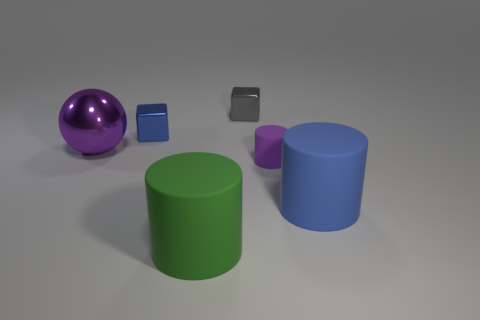Subtract 1 cylinders. How many cylinders are left? 2 Add 2 yellow things. How many objects exist? 8 Subtract all red blocks. Subtract all blue cylinders. How many blocks are left? 2 Subtract all cubes. How many objects are left? 4 Add 3 large purple shiny spheres. How many large purple shiny spheres exist? 4 Subtract 1 green cylinders. How many objects are left? 5 Subtract all large cyan shiny objects. Subtract all purple spheres. How many objects are left? 5 Add 4 large blue rubber cylinders. How many large blue rubber cylinders are left? 5 